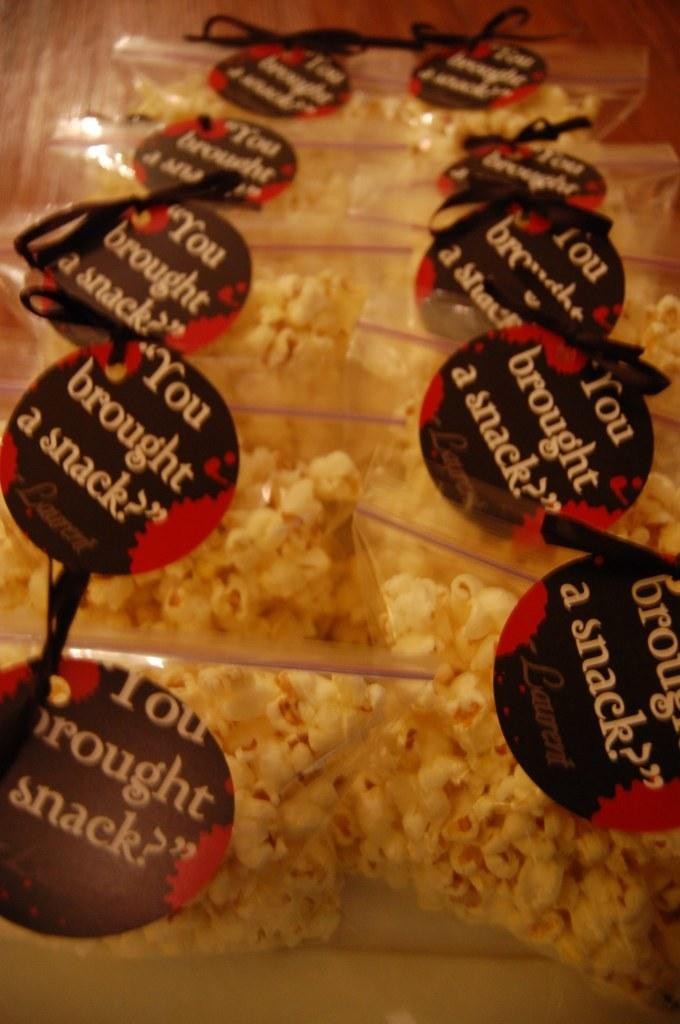What type of food is featured in the image? There are popcorn packs in the image. Can you describe any additional features of the popcorn packs? The popcorn packs have tags. What type of system is used to cook the popcorn in the image? There is no system or cooking process depicted in the image; it only shows popcorn packs with tags. 